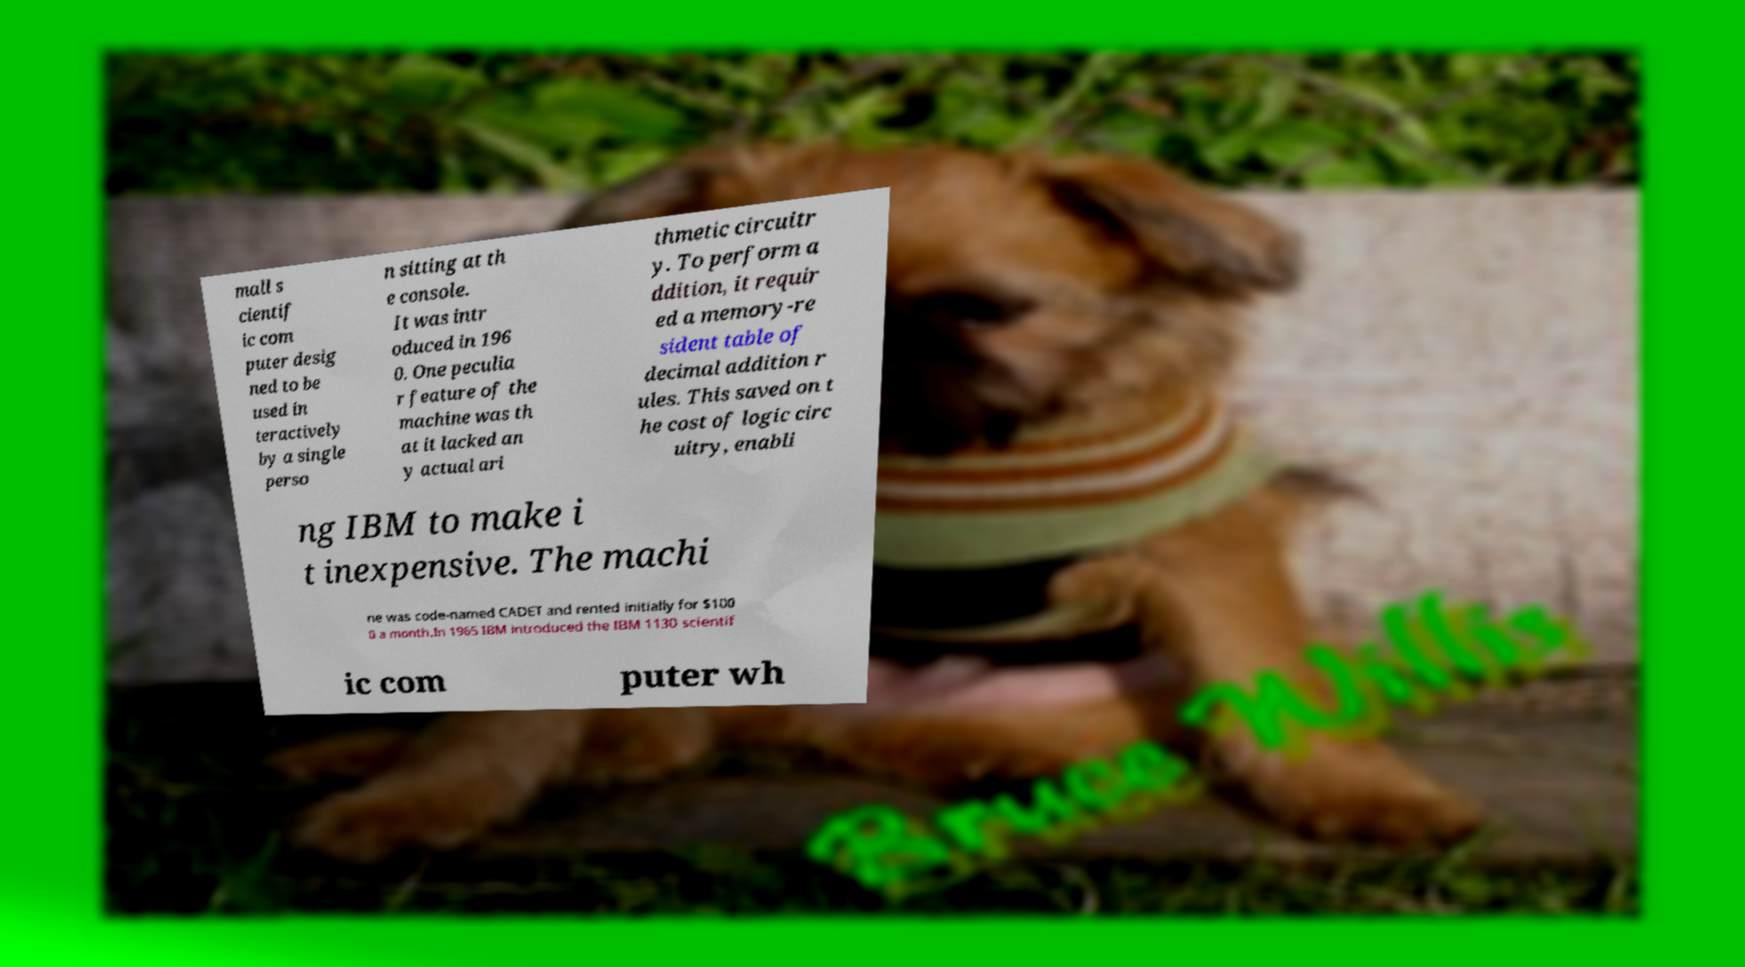Could you extract and type out the text from this image? mall s cientif ic com puter desig ned to be used in teractively by a single perso n sitting at th e console. It was intr oduced in 196 0. One peculia r feature of the machine was th at it lacked an y actual ari thmetic circuitr y. To perform a ddition, it requir ed a memory-re sident table of decimal addition r ules. This saved on t he cost of logic circ uitry, enabli ng IBM to make i t inexpensive. The machi ne was code-named CADET and rented initially for $100 0 a month.In 1965 IBM introduced the IBM 1130 scientif ic com puter wh 